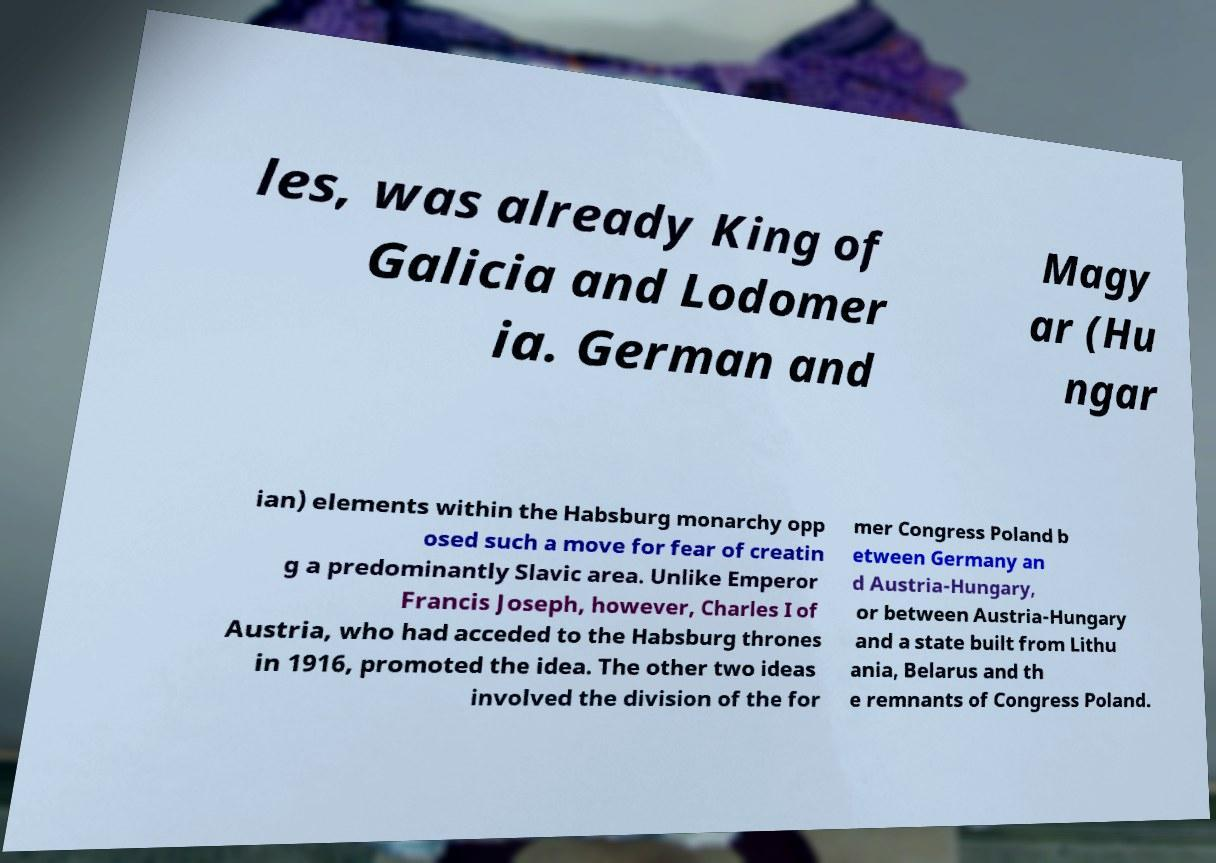Could you assist in decoding the text presented in this image and type it out clearly? les, was already King of Galicia and Lodomer ia. German and Magy ar (Hu ngar ian) elements within the Habsburg monarchy opp osed such a move for fear of creatin g a predominantly Slavic area. Unlike Emperor Francis Joseph, however, Charles I of Austria, who had acceded to the Habsburg thrones in 1916, promoted the idea. The other two ideas involved the division of the for mer Congress Poland b etween Germany an d Austria-Hungary, or between Austria-Hungary and a state built from Lithu ania, Belarus and th e remnants of Congress Poland. 